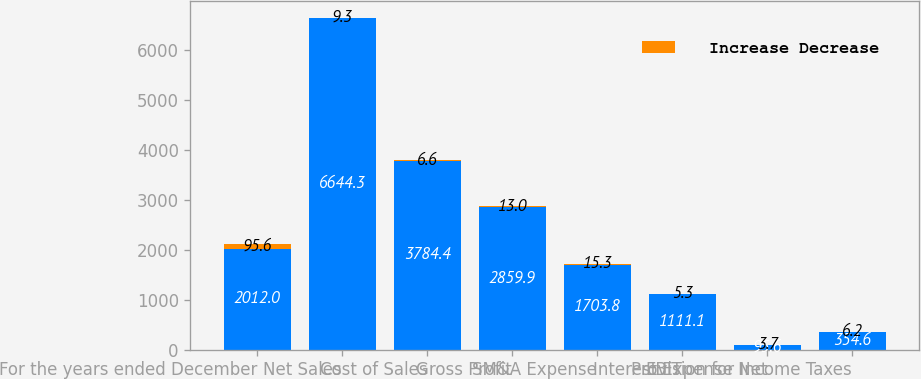<chart> <loc_0><loc_0><loc_500><loc_500><stacked_bar_chart><ecel><fcel>For the years ended December<fcel>Net Sales<fcel>Cost of Sales<fcel>Gross Profit<fcel>SM&A Expense<fcel>EBIT<fcel>Interest Expense Net<fcel>Provision for Income Taxes<nl><fcel>nan<fcel>2012<fcel>6644.3<fcel>3784.4<fcel>2859.9<fcel>1703.8<fcel>1111.1<fcel>95.6<fcel>354.6<nl><fcel>Increase Decrease<fcel>95.6<fcel>9.3<fcel>6.6<fcel>13<fcel>15.3<fcel>5.3<fcel>3.7<fcel>6.2<nl></chart> 